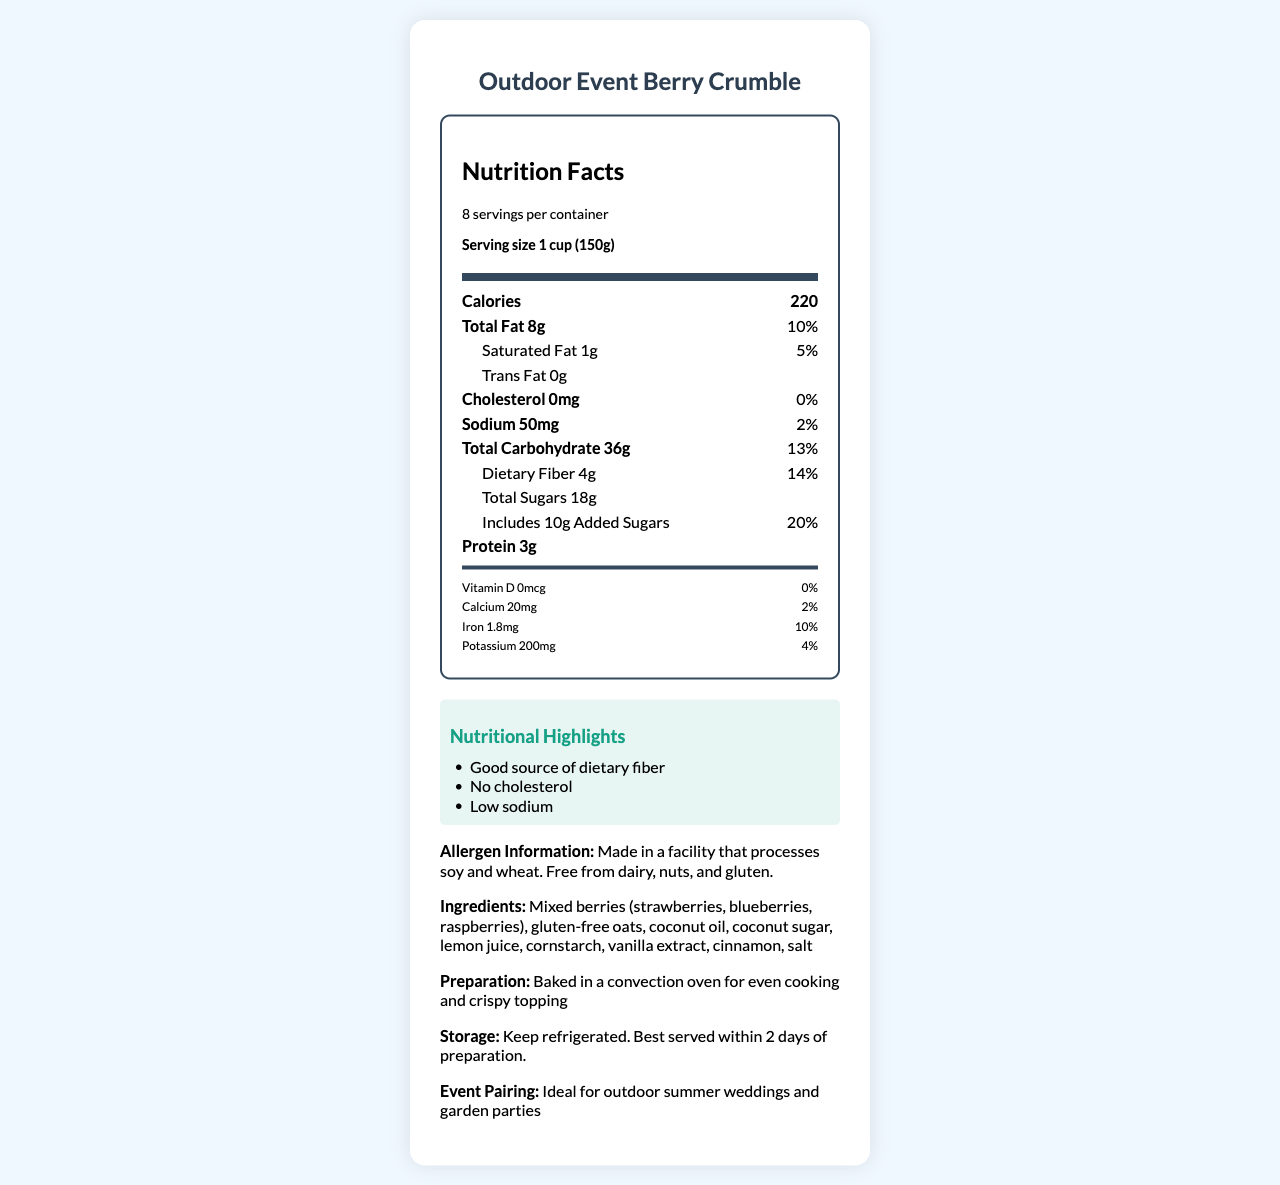what is the serving size? The serving size is stated clearly as "1 cup (150g)" in the nutrition facts label.
Answer: 1 cup (150g) how many servings are in one container? The document mentions that there are "8 servings per container."
Answer: 8 how many calories are there per serving? The calories per serving are listed directly as "220."
Answer: 220 what is the total fat content per serving? The total fat content per serving is listed as "Total Fat 8g."
Answer: 8g what percentage of the daily value is the vitamin D content? The vitamin D content is stated as "0mcg" with a daily value of "0%."
Answer: 0% which of the following nutrients has the highest daily value percentage? A. Total Fat B. Dietary Fiber C. Added Sugars Added Sugars has a daily value of 20%, which is the highest among the options listed.
Answer: C which ingredient is not included in the berry crumble? A. Coconut sugar B. Almonds C. Lemon juice D. Vanilla extract Almonds are not included in the list of ingredients; the label states the dessert is free from nuts.
Answer: B is the dessert gluten-free? The allergen information states it is "Free from dairy, nuts, and gluten."
Answer: Yes summarize the allergen information provided for the dessert. This is a summary of the allergen information provided in the document.
Answer: The dessert is made in a facility that processes soy and wheat but is free from dairy, nuts, and gluten. describe the main idea of the document. The document focuses on presenting comprehensive nutritional and ingredient information for the "Outdoor Event Berry Crumble" dessert, emphasizing its suitability for those with dietary restrictions.
Answer: The document provides a detailed nutrition facts label for a dairy-free, nut-free berry crumble, including serving size, caloric content, nutrient percentages, allergen information, ingredients, preparation method, storage instructions, and an event pairing suggestion. what is the total carbohydrate content per serving, and what percentage of the daily value does it represent? The total carbohydrate content per serving is "36g," which represents "13%" of the daily value.
Answer: 36g, 13% how is the dessert best stored? The storage instructions specify to keep the dessert refrigerated and that it is best served within 2 days of preparation.
Answer: Keep refrigerated, best served within 2 days of preparation. how is the dessert prepared? The preparation method mentioned is baking in a convection oven.
Answer: Baked in a convection oven for even cooking and crispy topping. what ingredient contributes to the dessert's fiber content? The dietary fiber content likely comes from the gluten-free oats listed in the ingredients.
Answer: Gluten-free oats what is the total sugar content per serving? The document states that the total sugar content per serving is "18g."
Answer: 18g does the dessert have any cholesterol? The cholesterol amount is stated as "0mg" with a daily value of "0%."
Answer: No can we determine if the dessert is vegan-friendly based on the information provided? The document does not provide explicit information on whether all ingredients are vegan, so this cannot be determined from the provided details.
Answer: I don't know 